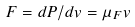Convert formula to latex. <formula><loc_0><loc_0><loc_500><loc_500>F = d P / d v = \mu _ { F } v</formula> 